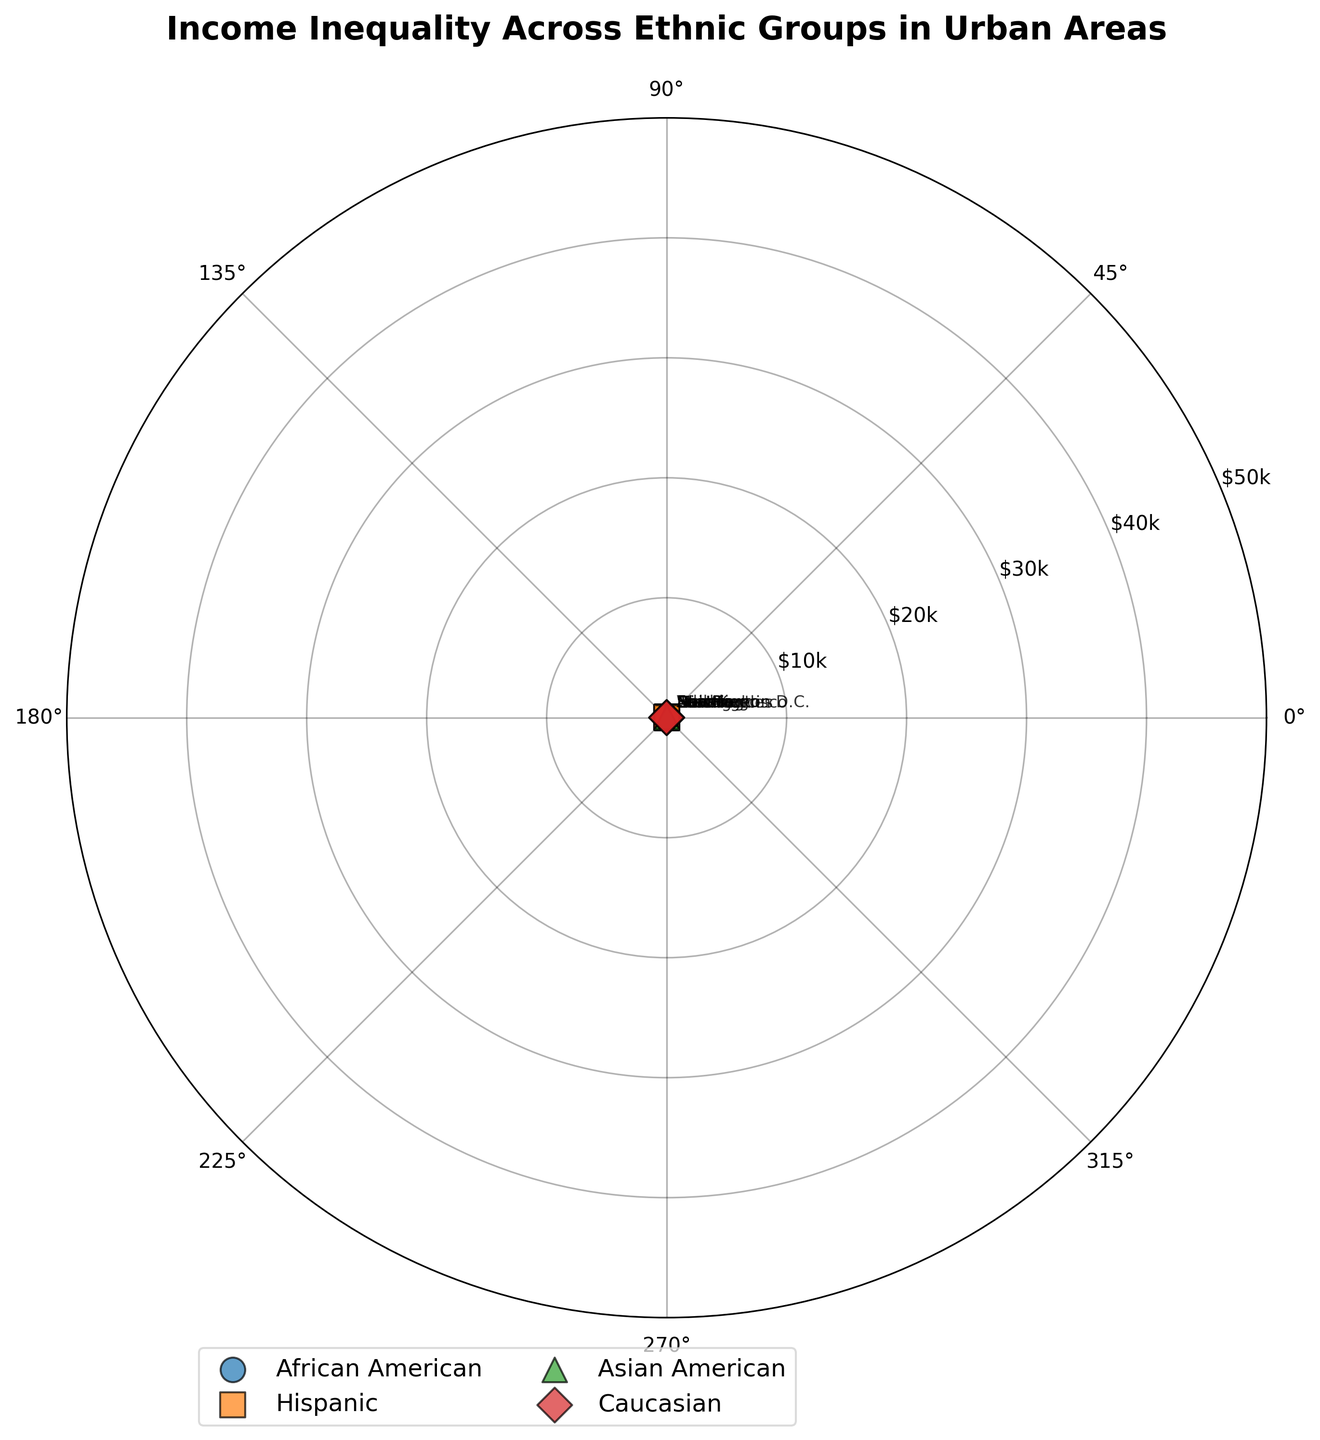What is the title of the figure? The title is often located at the top of the figure and describes the content being depicted. In this case, it serves to summarize the focus of the chart.
Answer: Income Inequality Across Ethnic Groups in Urban Areas Which ethnic group is represented by the triangle marker? The legend typically contains markers that correspond to each ethnic group. The triangle marker in this figure represents one specific group.
Answer: Asian American What is the income level range depicted on the y-axis? The y-axis represents income levels, and the range can be deduced from the radial distance settings and labels. In this figure, the radial labels indicate the income range.
Answer: $10k to $50k How many urban areas are considered in the figure? Each data point represents an urban area, and each point is labeled with the name of a city. Counting these labels tells us how many areas are included.
Answer: 12 What is the average income level for Caucasians in the figure? By identifying the data points for Caucasians and summing their income levels, then dividing by the number of points, we can find the average income.
Answer: ($45k + $47k + $46k) / 3 = $46k Which ethnic group has the lowest income depicted in the figure? By comparing all the data points for each ethnic group, the group with the smallest radial distance (income level) can be identified.
Answer: Hispanic What is the range of angles spanned by the African American data points? By noting the angles for each data point related to African Americans, we can calculate the difference between the smallest and largest angles.
Answer: 30° - 10° = 20° Which city is represented by the data point at the highest income level? The point closest to the outermost ring in the radial direction has the highest income level, and the city label of that point gives the answer.
Answer: Atlanta Are there more urban areas with incomes above $40k or below $30k for any ethnic group? Count the data points for each subgroup that exceed $40k and those that are below $30k, then compare these numbers.
Answer: Above $40k What is the income inequality between Hispanic and Caucasian groups based on their average income levels? Calculate the average income for each group and find the difference between the two averages.
Answer: $46k (Caucasian) - $21.67k (Hispanic) = $24.33k 